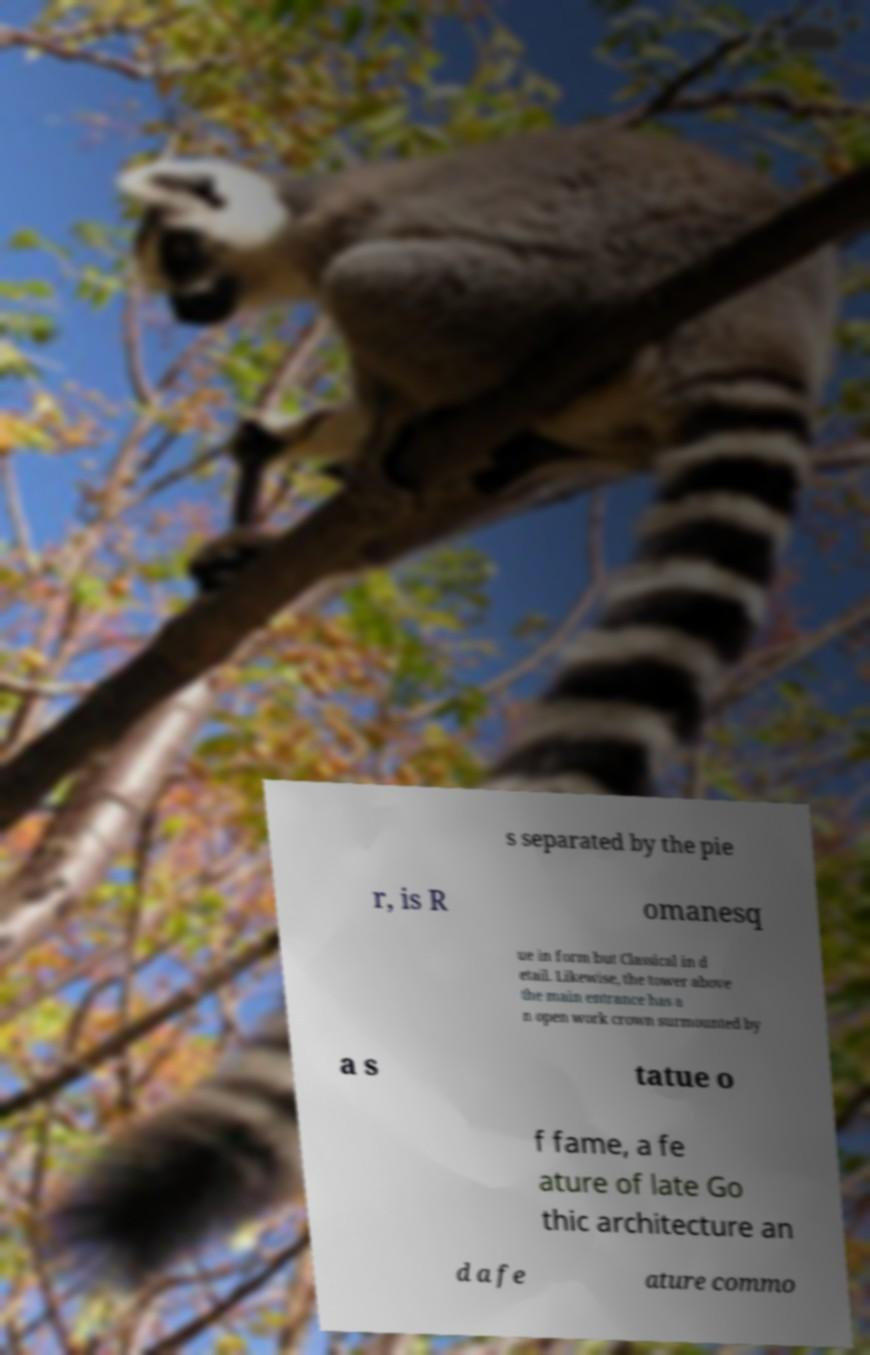Please identify and transcribe the text found in this image. s separated by the pie r, is R omanesq ue in form but Classical in d etail. Likewise, the tower above the main entrance has a n open work crown surmounted by a s tatue o f fame, a fe ature of late Go thic architecture an d a fe ature commo 